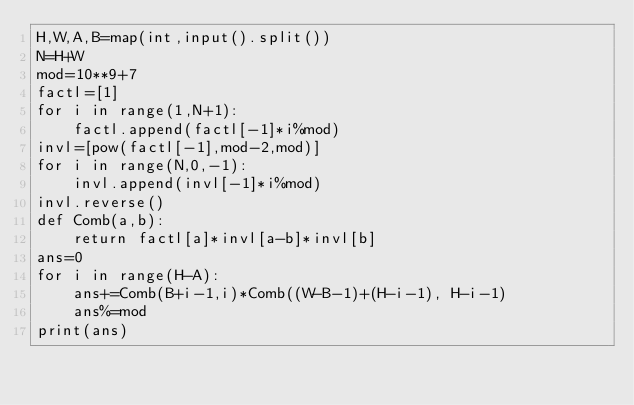Convert code to text. <code><loc_0><loc_0><loc_500><loc_500><_Python_>H,W,A,B=map(int,input().split())
N=H+W
mod=10**9+7
factl=[1]
for i in range(1,N+1):
    factl.append(factl[-1]*i%mod)
invl=[pow(factl[-1],mod-2,mod)]
for i in range(N,0,-1):
    invl.append(invl[-1]*i%mod)
invl.reverse()
def Comb(a,b):
    return factl[a]*invl[a-b]*invl[b]
ans=0
for i in range(H-A):
    ans+=Comb(B+i-1,i)*Comb((W-B-1)+(H-i-1), H-i-1)
    ans%=mod
print(ans)</code> 